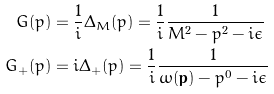<formula> <loc_0><loc_0><loc_500><loc_500>G ( p ) & = \frac { 1 } { i } \Delta _ { M } ( p ) = \frac { 1 } { i } \frac { 1 } { M ^ { 2 } - p ^ { 2 } - i \epsilon } \\ G _ { + } ( p ) & = i \Delta _ { + } ( p ) = \frac { 1 } { i } \frac { 1 } { \omega ( \mathbf p ) - p ^ { 0 } - i \epsilon }</formula> 